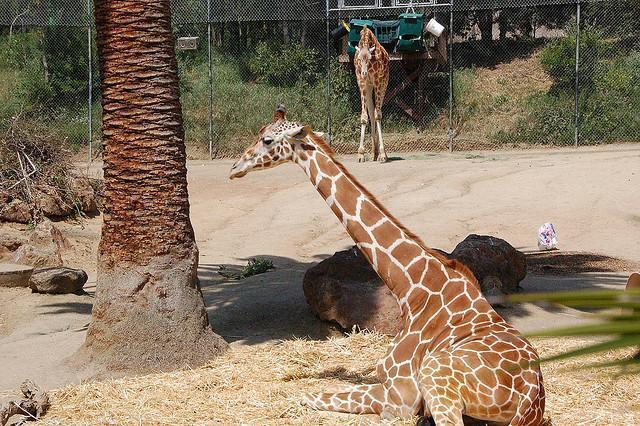What state of mind is the giraffe most likely in?
Choose the correct response and explain in the format: 'Answer: answer
Rationale: rationale.'
Options: Angry, anxious, upset, relaxed. Answer: relaxed.
Rationale: The giraffe is resting. 